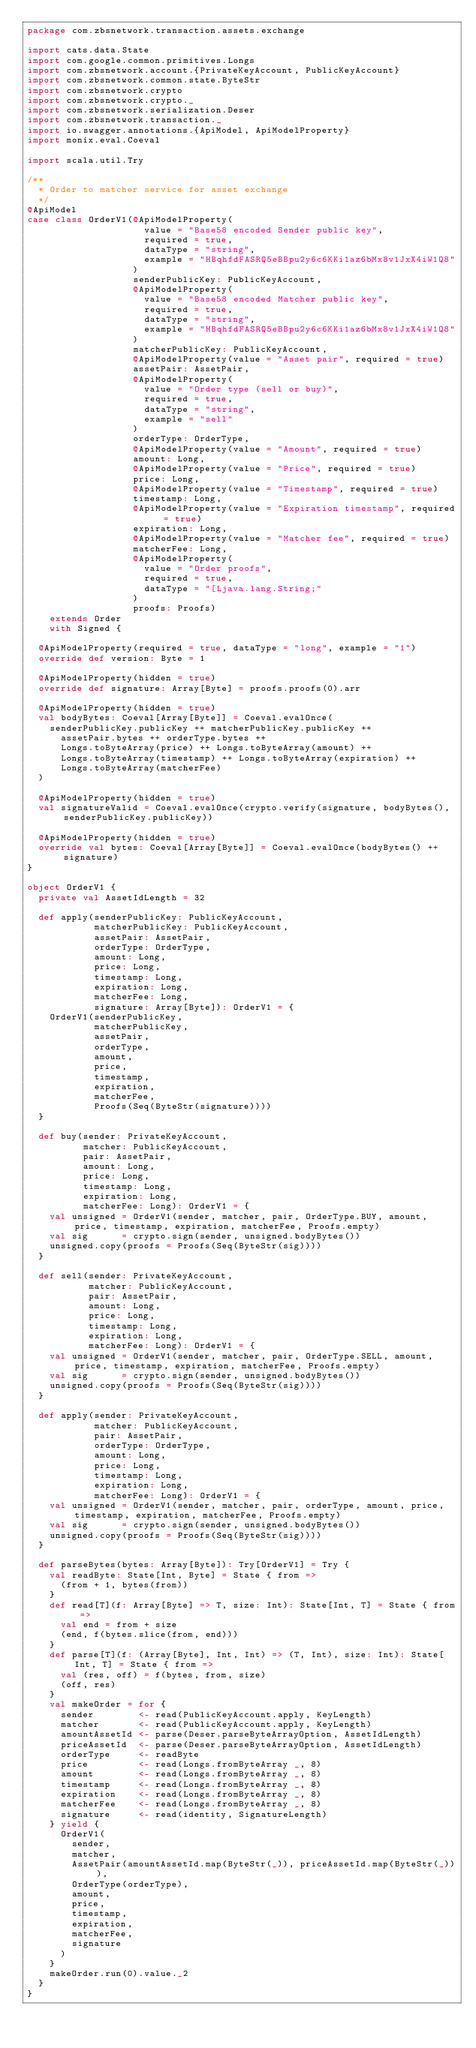Convert code to text. <code><loc_0><loc_0><loc_500><loc_500><_Scala_>package com.zbsnetwork.transaction.assets.exchange

import cats.data.State
import com.google.common.primitives.Longs
import com.zbsnetwork.account.{PrivateKeyAccount, PublicKeyAccount}
import com.zbsnetwork.common.state.ByteStr
import com.zbsnetwork.crypto
import com.zbsnetwork.crypto._
import com.zbsnetwork.serialization.Deser
import com.zbsnetwork.transaction._
import io.swagger.annotations.{ApiModel, ApiModelProperty}
import monix.eval.Coeval

import scala.util.Try

/**
  * Order to matcher service for asset exchange
  */
@ApiModel
case class OrderV1(@ApiModelProperty(
                     value = "Base58 encoded Sender public key",
                     required = true,
                     dataType = "string",
                     example = "HBqhfdFASRQ5eBBpu2y6c6KKi1az6bMx8v1JxX4iW1Q8"
                   )
                   senderPublicKey: PublicKeyAccount,
                   @ApiModelProperty(
                     value = "Base58 encoded Matcher public key",
                     required = true,
                     dataType = "string",
                     example = "HBqhfdFASRQ5eBBpu2y6c6KKi1az6bMx8v1JxX4iW1Q8"
                   )
                   matcherPublicKey: PublicKeyAccount,
                   @ApiModelProperty(value = "Asset pair", required = true)
                   assetPair: AssetPair,
                   @ApiModelProperty(
                     value = "Order type (sell or buy)",
                     required = true,
                     dataType = "string",
                     example = "sell"
                   )
                   orderType: OrderType,
                   @ApiModelProperty(value = "Amount", required = true)
                   amount: Long,
                   @ApiModelProperty(value = "Price", required = true)
                   price: Long,
                   @ApiModelProperty(value = "Timestamp", required = true)
                   timestamp: Long,
                   @ApiModelProperty(value = "Expiration timestamp", required = true)
                   expiration: Long,
                   @ApiModelProperty(value = "Matcher fee", required = true)
                   matcherFee: Long,
                   @ApiModelProperty(
                     value = "Order proofs",
                     required = true,
                     dataType = "[Ljava.lang.String;"
                   )
                   proofs: Proofs)
    extends Order
    with Signed {

  @ApiModelProperty(required = true, dataType = "long", example = "1")
  override def version: Byte = 1

  @ApiModelProperty(hidden = true)
  override def signature: Array[Byte] = proofs.proofs(0).arr

  @ApiModelProperty(hidden = true)
  val bodyBytes: Coeval[Array[Byte]] = Coeval.evalOnce(
    senderPublicKey.publicKey ++ matcherPublicKey.publicKey ++
      assetPair.bytes ++ orderType.bytes ++
      Longs.toByteArray(price) ++ Longs.toByteArray(amount) ++
      Longs.toByteArray(timestamp) ++ Longs.toByteArray(expiration) ++
      Longs.toByteArray(matcherFee)
  )

  @ApiModelProperty(hidden = true)
  val signatureValid = Coeval.evalOnce(crypto.verify(signature, bodyBytes(), senderPublicKey.publicKey))

  @ApiModelProperty(hidden = true)
  override val bytes: Coeval[Array[Byte]] = Coeval.evalOnce(bodyBytes() ++ signature)
}

object OrderV1 {
  private val AssetIdLength = 32

  def apply(senderPublicKey: PublicKeyAccount,
            matcherPublicKey: PublicKeyAccount,
            assetPair: AssetPair,
            orderType: OrderType,
            amount: Long,
            price: Long,
            timestamp: Long,
            expiration: Long,
            matcherFee: Long,
            signature: Array[Byte]): OrderV1 = {
    OrderV1(senderPublicKey,
            matcherPublicKey,
            assetPair,
            orderType,
            amount,
            price,
            timestamp,
            expiration,
            matcherFee,
            Proofs(Seq(ByteStr(signature))))
  }

  def buy(sender: PrivateKeyAccount,
          matcher: PublicKeyAccount,
          pair: AssetPair,
          amount: Long,
          price: Long,
          timestamp: Long,
          expiration: Long,
          matcherFee: Long): OrderV1 = {
    val unsigned = OrderV1(sender, matcher, pair, OrderType.BUY, amount, price, timestamp, expiration, matcherFee, Proofs.empty)
    val sig      = crypto.sign(sender, unsigned.bodyBytes())
    unsigned.copy(proofs = Proofs(Seq(ByteStr(sig))))
  }

  def sell(sender: PrivateKeyAccount,
           matcher: PublicKeyAccount,
           pair: AssetPair,
           amount: Long,
           price: Long,
           timestamp: Long,
           expiration: Long,
           matcherFee: Long): OrderV1 = {
    val unsigned = OrderV1(sender, matcher, pair, OrderType.SELL, amount, price, timestamp, expiration, matcherFee, Proofs.empty)
    val sig      = crypto.sign(sender, unsigned.bodyBytes())
    unsigned.copy(proofs = Proofs(Seq(ByteStr(sig))))
  }

  def apply(sender: PrivateKeyAccount,
            matcher: PublicKeyAccount,
            pair: AssetPair,
            orderType: OrderType,
            amount: Long,
            price: Long,
            timestamp: Long,
            expiration: Long,
            matcherFee: Long): OrderV1 = {
    val unsigned = OrderV1(sender, matcher, pair, orderType, amount, price, timestamp, expiration, matcherFee, Proofs.empty)
    val sig      = crypto.sign(sender, unsigned.bodyBytes())
    unsigned.copy(proofs = Proofs(Seq(ByteStr(sig))))
  }

  def parseBytes(bytes: Array[Byte]): Try[OrderV1] = Try {
    val readByte: State[Int, Byte] = State { from =>
      (from + 1, bytes(from))
    }
    def read[T](f: Array[Byte] => T, size: Int): State[Int, T] = State { from =>
      val end = from + size
      (end, f(bytes.slice(from, end)))
    }
    def parse[T](f: (Array[Byte], Int, Int) => (T, Int), size: Int): State[Int, T] = State { from =>
      val (res, off) = f(bytes, from, size)
      (off, res)
    }
    val makeOrder = for {
      sender        <- read(PublicKeyAccount.apply, KeyLength)
      matcher       <- read(PublicKeyAccount.apply, KeyLength)
      amountAssetId <- parse(Deser.parseByteArrayOption, AssetIdLength)
      priceAssetId  <- parse(Deser.parseByteArrayOption, AssetIdLength)
      orderType     <- readByte
      price         <- read(Longs.fromByteArray _, 8)
      amount        <- read(Longs.fromByteArray _, 8)
      timestamp     <- read(Longs.fromByteArray _, 8)
      expiration    <- read(Longs.fromByteArray _, 8)
      matcherFee    <- read(Longs.fromByteArray _, 8)
      signature     <- read(identity, SignatureLength)
    } yield {
      OrderV1(
        sender,
        matcher,
        AssetPair(amountAssetId.map(ByteStr(_)), priceAssetId.map(ByteStr(_))),
        OrderType(orderType),
        amount,
        price,
        timestamp,
        expiration,
        matcherFee,
        signature
      )
    }
    makeOrder.run(0).value._2
  }
}
</code> 